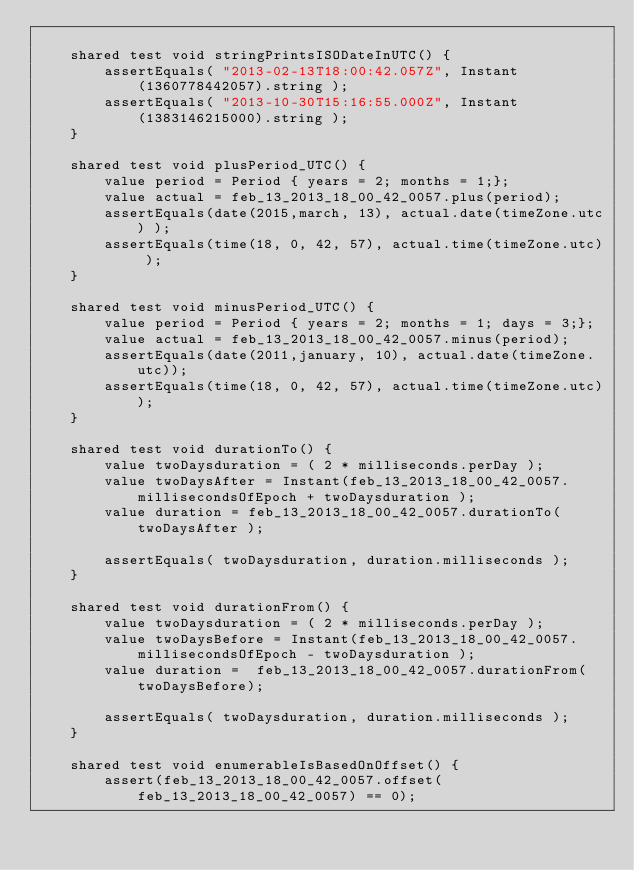<code> <loc_0><loc_0><loc_500><loc_500><_Ceylon_>    
    shared test void stringPrintsISODateInUTC() {
        assertEquals( "2013-02-13T18:00:42.057Z", Instant(1360778442057).string );
        assertEquals( "2013-10-30T15:16:55.000Z", Instant(1383146215000).string );
    }
    
    shared test void plusPeriod_UTC() {
        value period = Period { years = 2; months = 1;};
        value actual = feb_13_2013_18_00_42_0057.plus(period);
        assertEquals(date(2015,march, 13), actual.date(timeZone.utc) );
        assertEquals(time(18, 0, 42, 57), actual.time(timeZone.utc) );
    }
    
    shared test void minusPeriod_UTC() {
        value period = Period { years = 2; months = 1; days = 3;};
        value actual = feb_13_2013_18_00_42_0057.minus(period);
        assertEquals(date(2011,january, 10), actual.date(timeZone.utc));
        assertEquals(time(18, 0, 42, 57), actual.time(timeZone.utc));
    }
    
    shared test void durationTo() {
        value twoDaysduration = ( 2 * milliseconds.perDay );
        value twoDaysAfter = Instant(feb_13_2013_18_00_42_0057.millisecondsOfEpoch + twoDaysduration );
        value duration = feb_13_2013_18_00_42_0057.durationTo( twoDaysAfter );
        
        assertEquals( twoDaysduration, duration.milliseconds );
    }
    
    shared test void durationFrom() {
        value twoDaysduration = ( 2 * milliseconds.perDay );
        value twoDaysBefore = Instant(feb_13_2013_18_00_42_0057.millisecondsOfEpoch - twoDaysduration );
        value duration =  feb_13_2013_18_00_42_0057.durationFrom(twoDaysBefore);
        
        assertEquals( twoDaysduration, duration.milliseconds );
    }
    
    shared test void enumerableIsBasedOnOffset() {
        assert(feb_13_2013_18_00_42_0057.offset(feb_13_2013_18_00_42_0057) == 0);</code> 